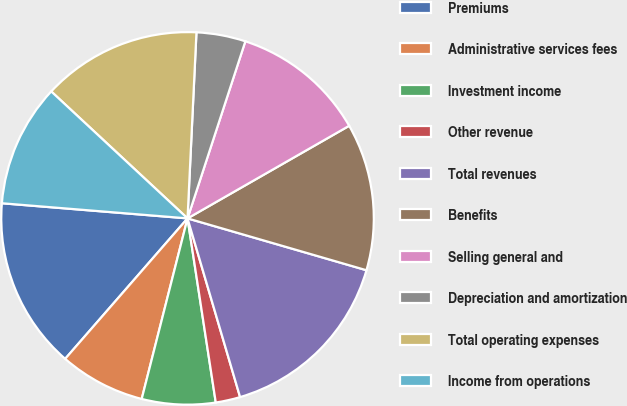Convert chart. <chart><loc_0><loc_0><loc_500><loc_500><pie_chart><fcel>Premiums<fcel>Administrative services fees<fcel>Investment income<fcel>Other revenue<fcel>Total revenues<fcel>Benefits<fcel>Selling general and<fcel>Depreciation and amortization<fcel>Total operating expenses<fcel>Income from operations<nl><fcel>14.89%<fcel>7.45%<fcel>6.38%<fcel>2.13%<fcel>15.96%<fcel>12.77%<fcel>11.7%<fcel>4.26%<fcel>13.83%<fcel>10.64%<nl></chart> 